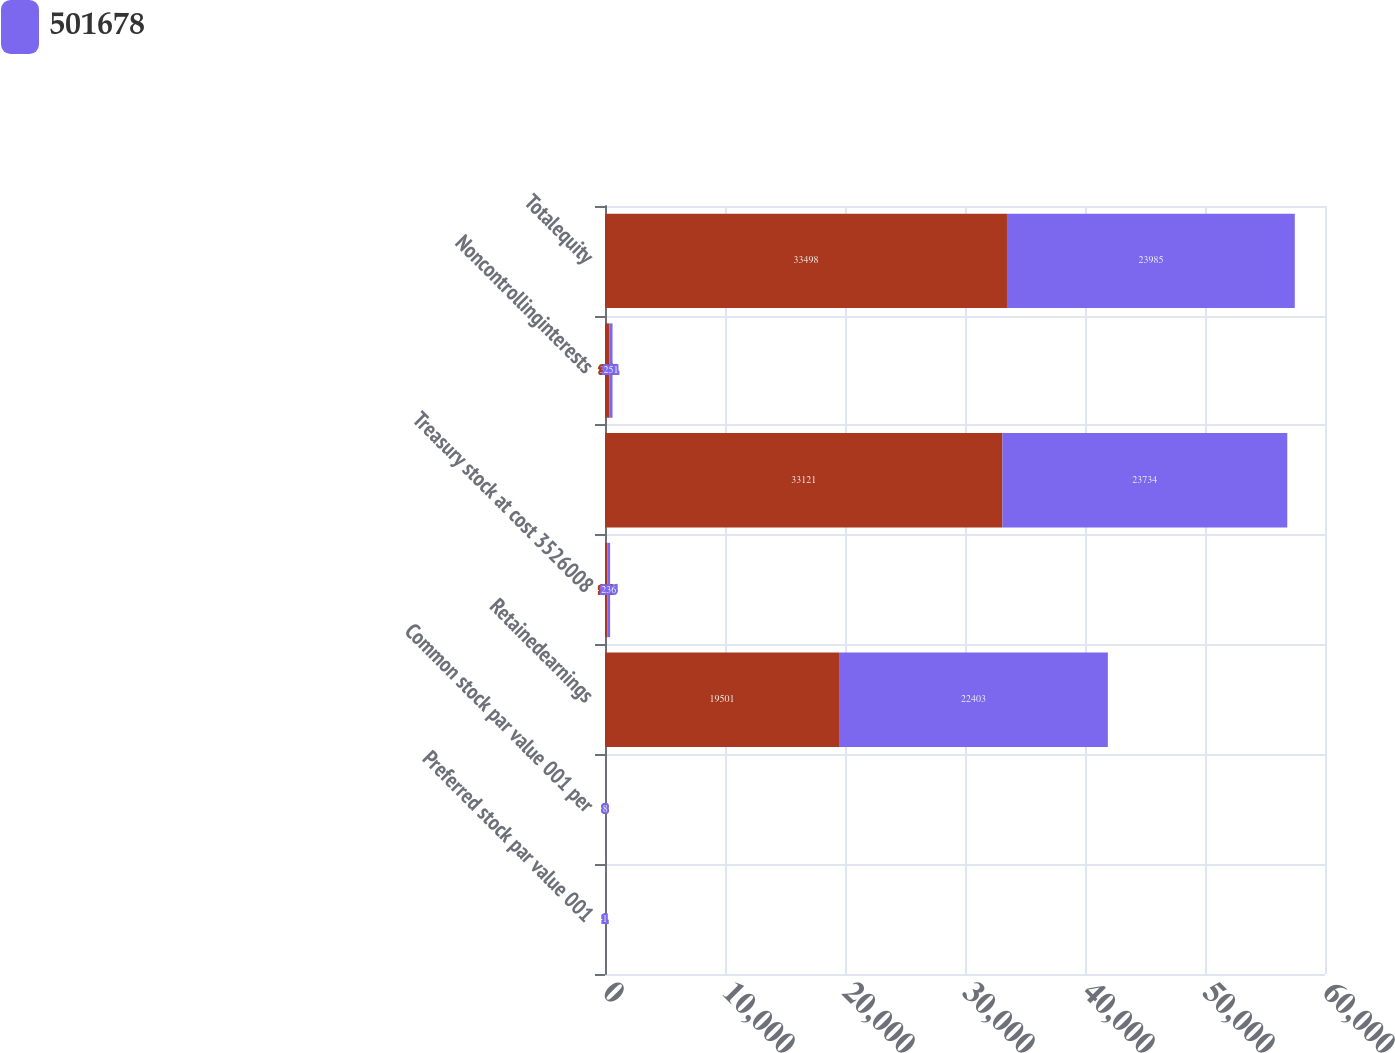Convert chart to OTSL. <chart><loc_0><loc_0><loc_500><loc_500><stacked_bar_chart><ecel><fcel>Preferred stock par value 001<fcel>Common stock par value 001 per<fcel>Retainedearnings<fcel>Treasury stock at cost 3526008<fcel>Unnamed: 5<fcel>Noncontrollinginterests<fcel>Totalequity<nl><fcel>nan<fcel>1<fcel>8<fcel>19501<fcel>190<fcel>33121<fcel>377<fcel>33498<nl><fcel>501678<fcel>1<fcel>8<fcel>22403<fcel>236<fcel>23734<fcel>251<fcel>23985<nl></chart> 